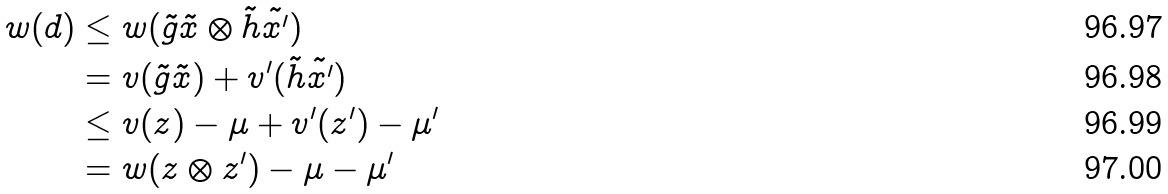<formula> <loc_0><loc_0><loc_500><loc_500>w ( d ) & \leq w ( \tilde { g } \tilde { x } \otimes \tilde { h } \tilde { x ^ { \prime } } ) \\ & = v ( \tilde { g } \tilde { x } ) + v ^ { \prime } ( \tilde { h } \tilde { x ^ { \prime } } ) \\ & \leq v ( z ) - \mu + v ^ { \prime } ( z ^ { \prime } ) - \mu ^ { \prime } \\ & = w ( z \otimes z ^ { \prime } ) - \mu - \mu ^ { \prime }</formula> 